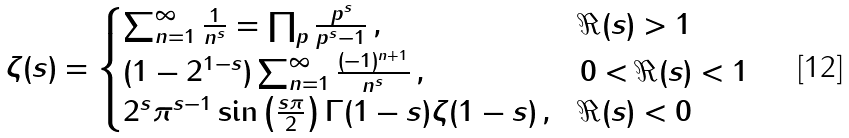<formula> <loc_0><loc_0><loc_500><loc_500>\zeta ( s ) = \begin{cases} \sum _ { n = 1 } ^ { \infty } \frac { 1 } { n ^ { s } } = \prod _ { p } \frac { p ^ { s } } { p ^ { s } - 1 } \, , & \Re ( s ) > 1 \\ ( 1 - 2 ^ { 1 - s } ) \sum _ { n = 1 } ^ { \infty } \frac { ( - 1 ) ^ { n + 1 } } { n ^ { s } } \, , & 0 < \Re ( s ) < 1 \\ 2 ^ { s } \pi ^ { s - 1 } \sin \left ( \frac { s \pi } { 2 } \right ) \Gamma ( 1 - s ) \zeta ( 1 - s ) \, , & \Re ( s ) < 0 \end{cases}</formula> 